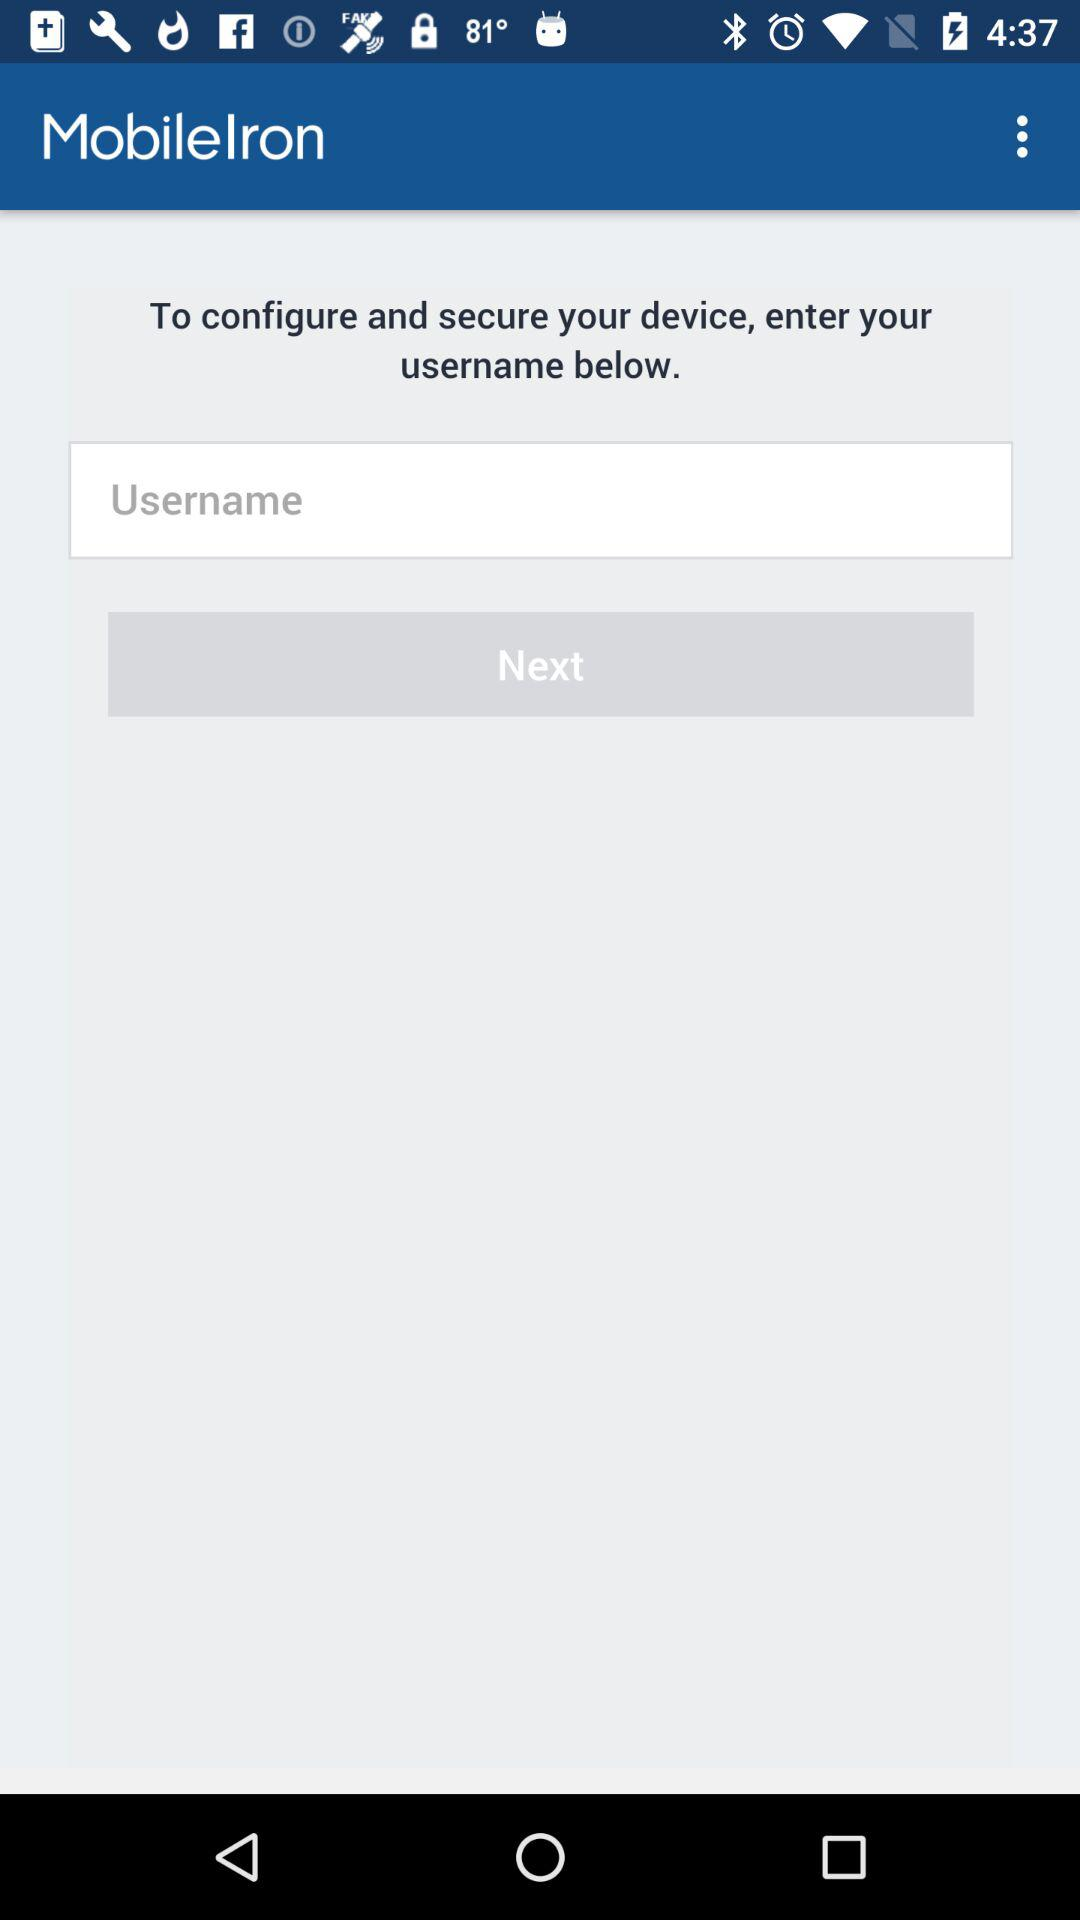What is the application name? The application name is "MobileIron". 